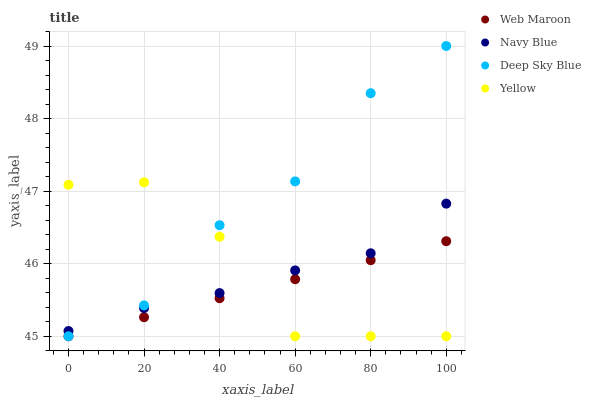Does Web Maroon have the minimum area under the curve?
Answer yes or no. Yes. Does Deep Sky Blue have the maximum area under the curve?
Answer yes or no. Yes. Does Yellow have the minimum area under the curve?
Answer yes or no. No. Does Yellow have the maximum area under the curve?
Answer yes or no. No. Is Web Maroon the smoothest?
Answer yes or no. Yes. Is Yellow the roughest?
Answer yes or no. Yes. Is Yellow the smoothest?
Answer yes or no. No. Is Web Maroon the roughest?
Answer yes or no. No. Does Web Maroon have the lowest value?
Answer yes or no. Yes. Does Deep Sky Blue have the highest value?
Answer yes or no. Yes. Does Yellow have the highest value?
Answer yes or no. No. Is Web Maroon less than Navy Blue?
Answer yes or no. Yes. Is Navy Blue greater than Web Maroon?
Answer yes or no. Yes. Does Web Maroon intersect Deep Sky Blue?
Answer yes or no. Yes. Is Web Maroon less than Deep Sky Blue?
Answer yes or no. No. Is Web Maroon greater than Deep Sky Blue?
Answer yes or no. No. Does Web Maroon intersect Navy Blue?
Answer yes or no. No. 